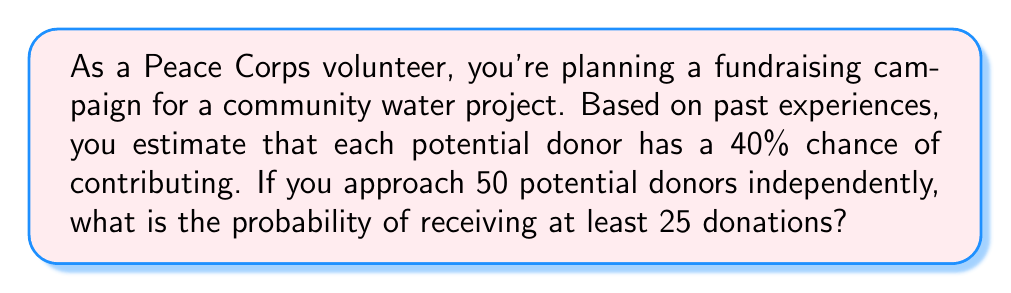Solve this math problem. Let's approach this step-by-step:

1) This scenario follows a binomial distribution. Let X be the number of donations received.

2) We have:
   n = 50 (number of potential donors)
   p = 0.40 (probability of each donor contributing)
   We want P(X ≥ 25)

3) Instead of calculating P(X ≥ 25) directly, it's easier to calculate 1 - P(X < 25)

4) We can use the normal approximation to the binomial distribution since np and n(1-p) are both greater than 5:
   np = 50 * 0.40 = 20 > 5
   n(1-p) = 50 * 0.60 = 30 > 5

5) For a normal approximation:
   μ = np = 50 * 0.40 = 20
   σ = √(np(1-p)) = √(50 * 0.40 * 0.60) ≈ 3.46

6) We need to apply a continuity correction. Instead of X < 25, we use X < 24.5

7) Standardizing:
   z = (24.5 - 20) / 3.46 ≈ 1.30

8) Using a standard normal table or calculator:
   P(Z < 1.30) ≈ 0.9032

9) Therefore:
   P(X ≥ 25) = 1 - P(X < 25) ≈ 1 - 0.9032 = 0.0968
Answer: 0.0968 or approximately 9.68% 